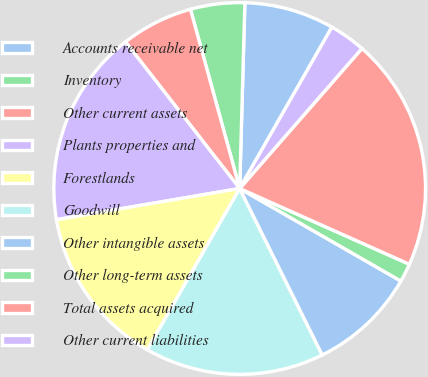Convert chart. <chart><loc_0><loc_0><loc_500><loc_500><pie_chart><fcel>Accounts receivable net<fcel>Inventory<fcel>Other current assets<fcel>Plants properties and<fcel>Forestlands<fcel>Goodwill<fcel>Other intangible assets<fcel>Other long-term assets<fcel>Total assets acquired<fcel>Other current liabilities<nl><fcel>7.82%<fcel>4.71%<fcel>6.27%<fcel>17.15%<fcel>14.04%<fcel>15.6%<fcel>9.38%<fcel>1.61%<fcel>20.26%<fcel>3.16%<nl></chart> 